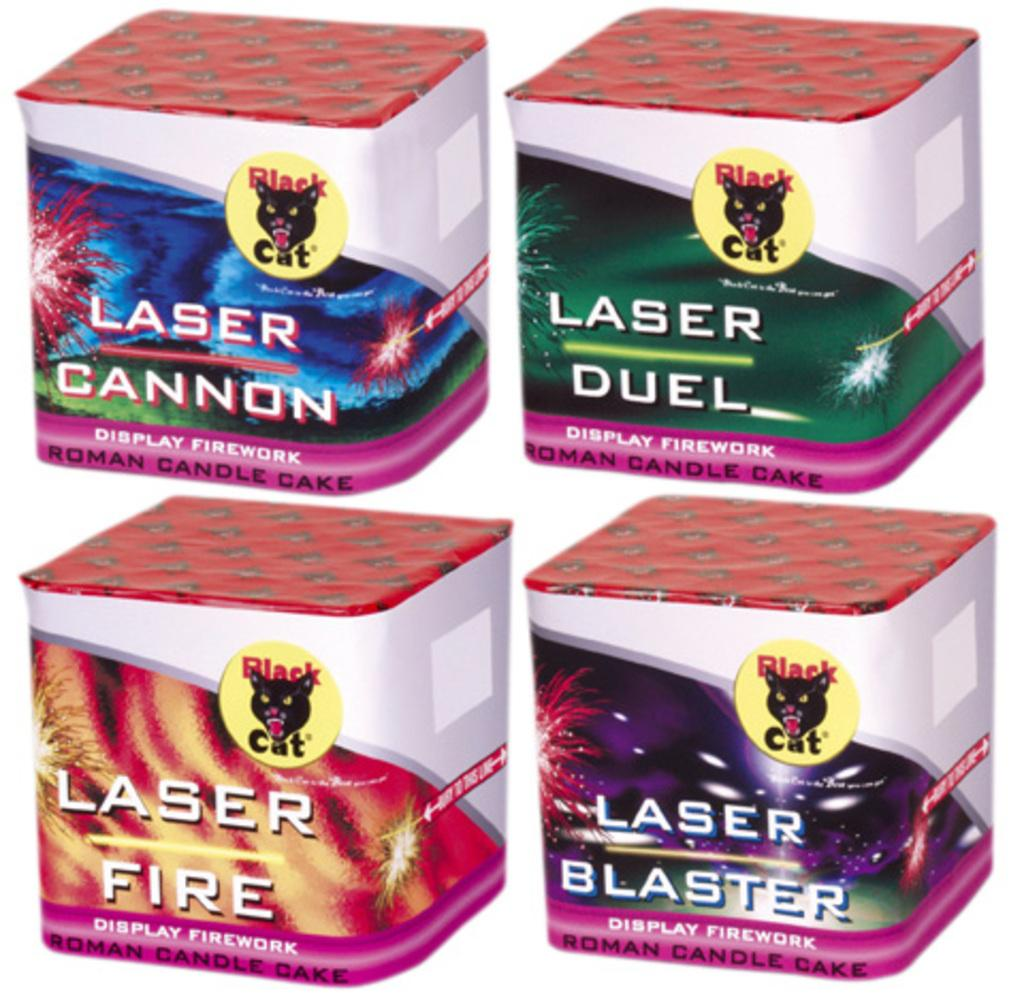<image>
Create a compact narrative representing the image presented. Four boxes of Laser Fire fireworks by Black Cat. 